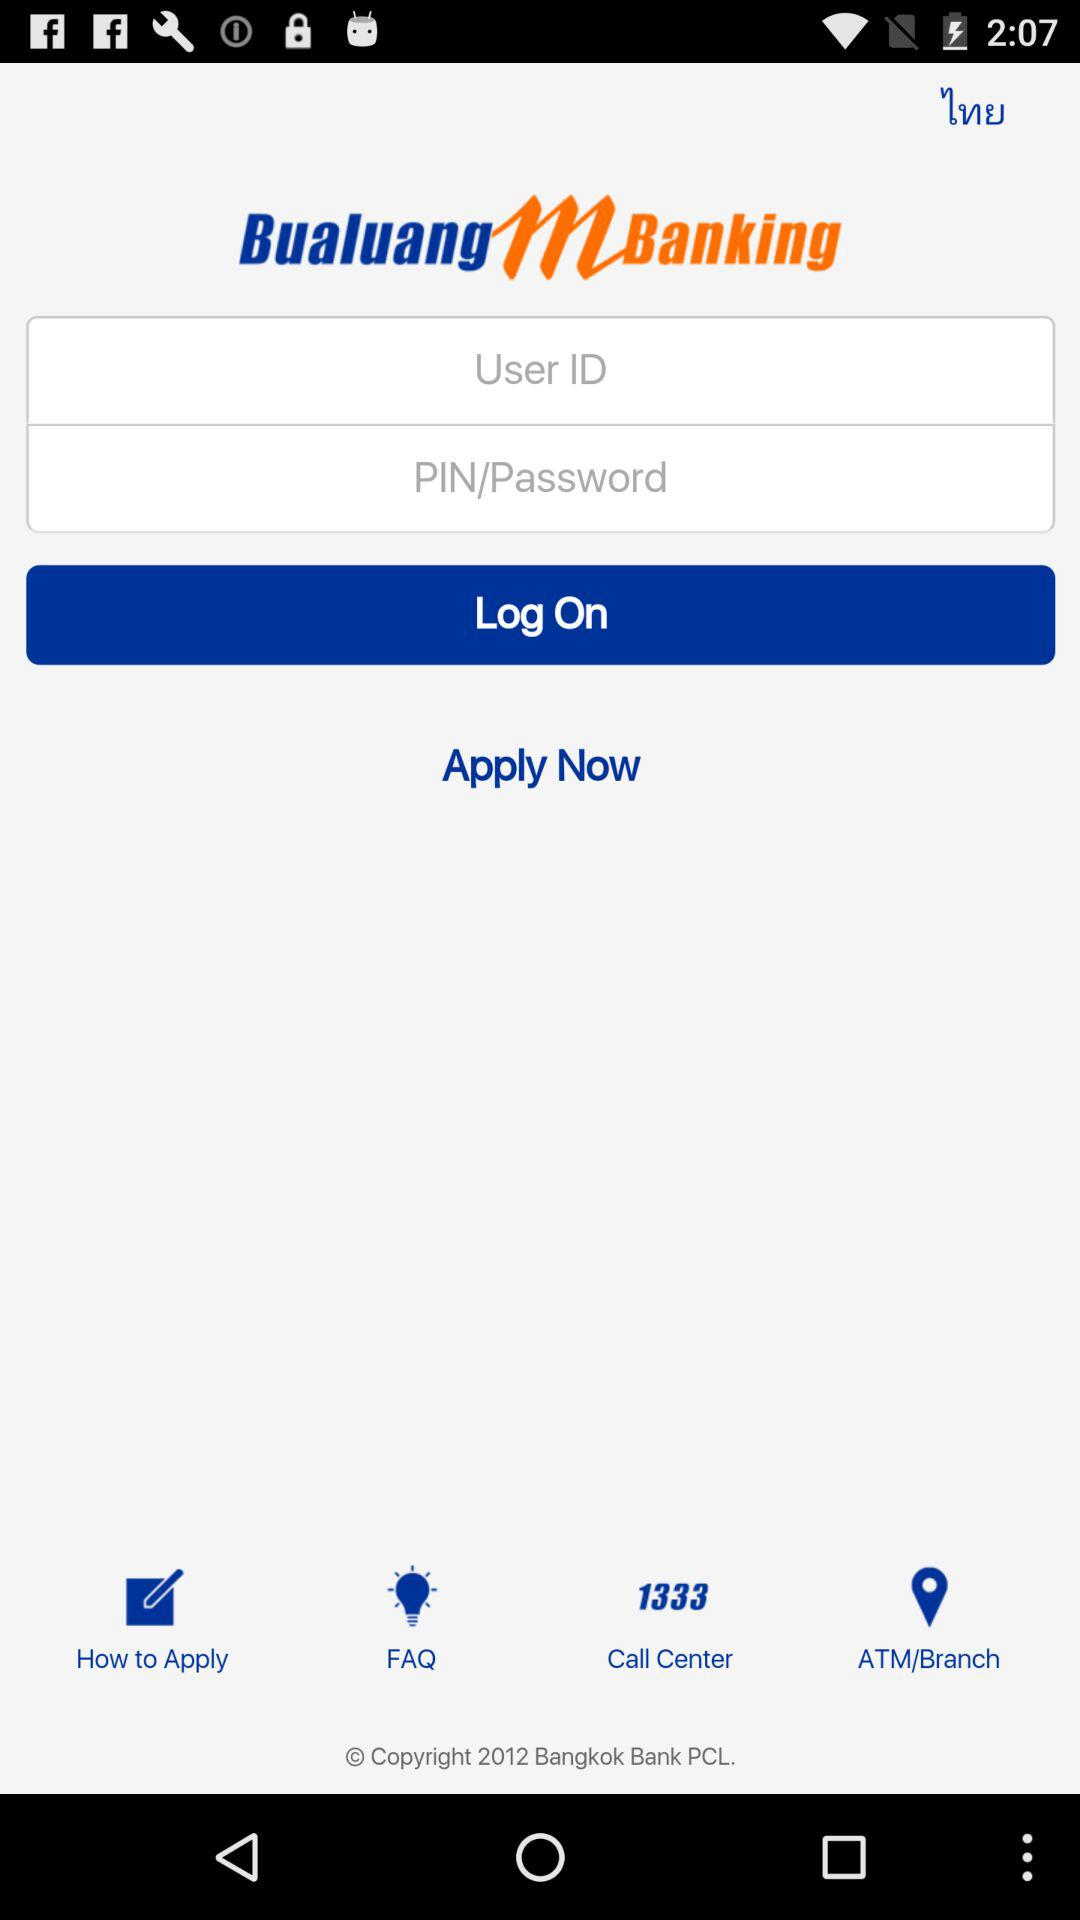What are the requirements to log in? The requirements to log in are "User ID" and "PIN/Password". 